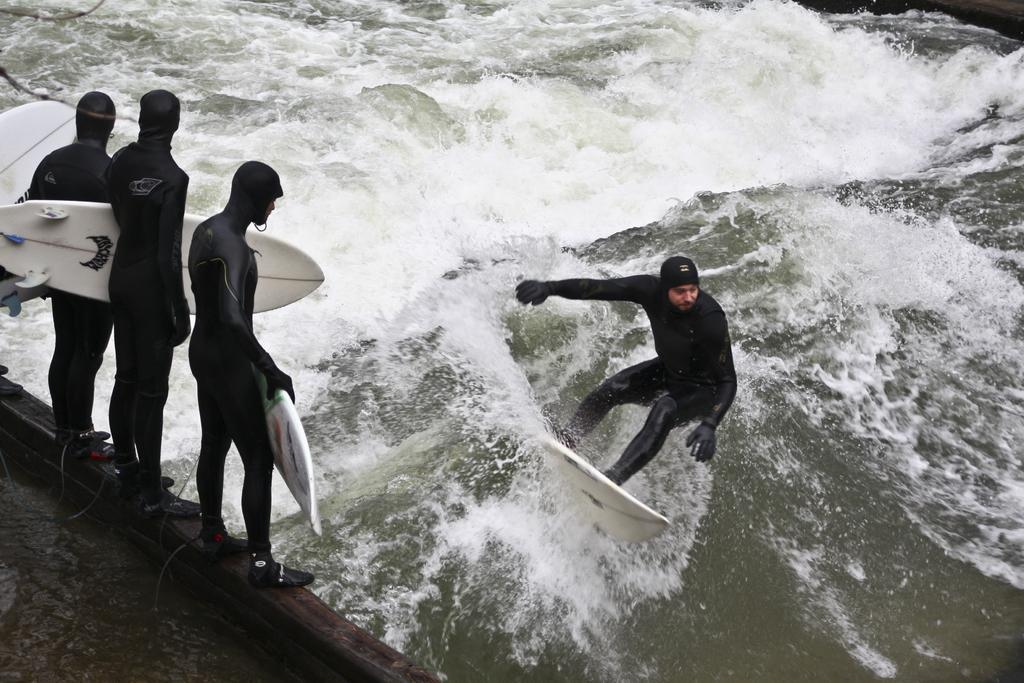Describe this image in one or two sentences. He was on top of a skateboard in the water. On the left side persons are holding a skateboard. 